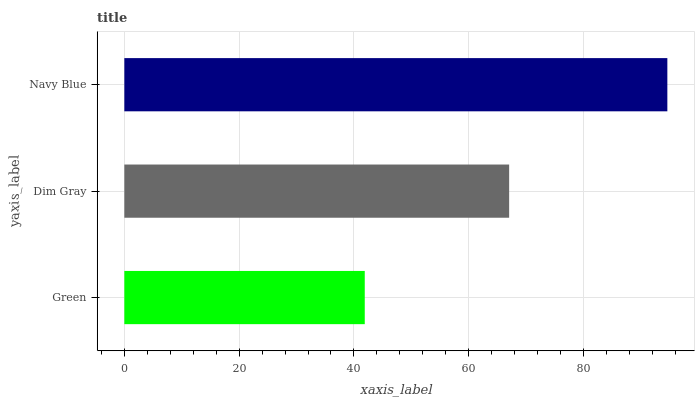Is Green the minimum?
Answer yes or no. Yes. Is Navy Blue the maximum?
Answer yes or no. Yes. Is Dim Gray the minimum?
Answer yes or no. No. Is Dim Gray the maximum?
Answer yes or no. No. Is Dim Gray greater than Green?
Answer yes or no. Yes. Is Green less than Dim Gray?
Answer yes or no. Yes. Is Green greater than Dim Gray?
Answer yes or no. No. Is Dim Gray less than Green?
Answer yes or no. No. Is Dim Gray the high median?
Answer yes or no. Yes. Is Dim Gray the low median?
Answer yes or no. Yes. Is Navy Blue the high median?
Answer yes or no. No. Is Green the low median?
Answer yes or no. No. 